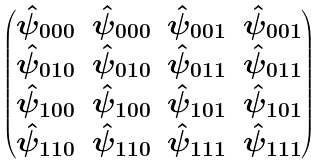Convert formula to latex. <formula><loc_0><loc_0><loc_500><loc_500>\begin{pmatrix} \hat { \psi } _ { 0 0 0 } & \hat { \psi } _ { 0 0 0 } & \hat { \psi } _ { 0 0 1 } & \hat { \psi } _ { 0 0 1 } \\ \hat { \psi } _ { 0 1 0 } & \hat { \psi } _ { 0 1 0 } & \hat { \psi } _ { 0 1 1 } & \hat { \psi } _ { 0 1 1 } \\ \hat { \psi } _ { 1 0 0 } & \hat { \psi } _ { 1 0 0 } & \hat { \psi } _ { 1 0 1 } & \hat { \psi } _ { 1 0 1 } \\ \hat { \psi } _ { 1 1 0 } & \hat { \psi } _ { 1 1 0 } & \hat { \psi } _ { 1 1 1 } & \hat { \psi } _ { 1 1 1 } \end{pmatrix}</formula> 